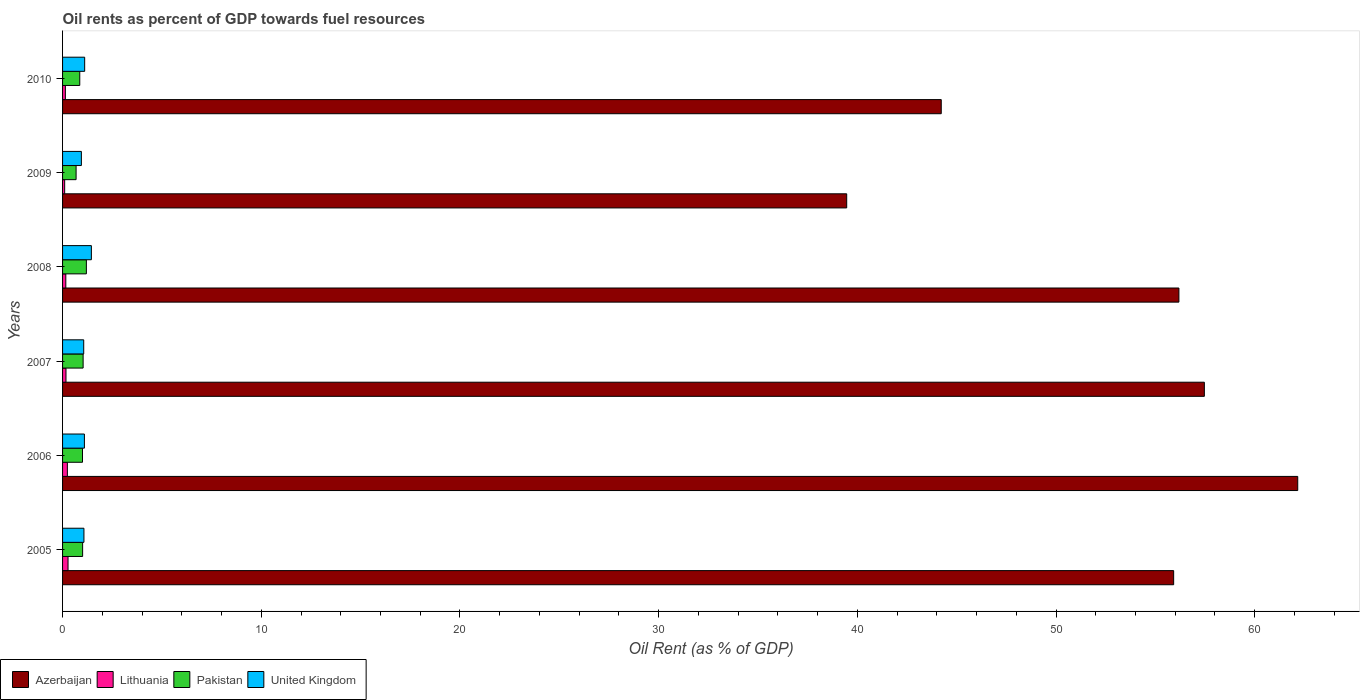Are the number of bars per tick equal to the number of legend labels?
Your answer should be compact. Yes. Are the number of bars on each tick of the Y-axis equal?
Keep it short and to the point. Yes. How many bars are there on the 4th tick from the top?
Ensure brevity in your answer.  4. What is the label of the 1st group of bars from the top?
Provide a succinct answer. 2010. In how many cases, is the number of bars for a given year not equal to the number of legend labels?
Your answer should be compact. 0. What is the oil rent in Lithuania in 2009?
Keep it short and to the point. 0.11. Across all years, what is the maximum oil rent in Pakistan?
Your response must be concise. 1.2. Across all years, what is the minimum oil rent in Azerbaijan?
Offer a very short reply. 39.47. In which year was the oil rent in Azerbaijan maximum?
Your answer should be compact. 2006. In which year was the oil rent in Azerbaijan minimum?
Your response must be concise. 2009. What is the total oil rent in Lithuania in the graph?
Provide a short and direct response. 1.1. What is the difference between the oil rent in United Kingdom in 2008 and that in 2009?
Offer a very short reply. 0.5. What is the difference between the oil rent in United Kingdom in 2009 and the oil rent in Azerbaijan in 2007?
Keep it short and to the point. -56.52. What is the average oil rent in Lithuania per year?
Your response must be concise. 0.18. In the year 2006, what is the difference between the oil rent in Lithuania and oil rent in Azerbaijan?
Your answer should be compact. -61.92. What is the ratio of the oil rent in Azerbaijan in 2005 to that in 2006?
Make the answer very short. 0.9. Is the oil rent in Pakistan in 2006 less than that in 2009?
Make the answer very short. No. What is the difference between the highest and the second highest oil rent in United Kingdom?
Your answer should be very brief. 0.34. What is the difference between the highest and the lowest oil rent in United Kingdom?
Keep it short and to the point. 0.5. Is it the case that in every year, the sum of the oil rent in Pakistan and oil rent in Lithuania is greater than the sum of oil rent in United Kingdom and oil rent in Azerbaijan?
Keep it short and to the point. No. What does the 4th bar from the top in 2008 represents?
Your answer should be compact. Azerbaijan. How many legend labels are there?
Provide a succinct answer. 4. How are the legend labels stacked?
Ensure brevity in your answer.  Horizontal. What is the title of the graph?
Your response must be concise. Oil rents as percent of GDP towards fuel resources. What is the label or title of the X-axis?
Provide a succinct answer. Oil Rent (as % of GDP). What is the label or title of the Y-axis?
Offer a very short reply. Years. What is the Oil Rent (as % of GDP) in Azerbaijan in 2005?
Provide a succinct answer. 55.92. What is the Oil Rent (as % of GDP) in Lithuania in 2005?
Offer a terse response. 0.28. What is the Oil Rent (as % of GDP) in Pakistan in 2005?
Provide a short and direct response. 1.01. What is the Oil Rent (as % of GDP) in United Kingdom in 2005?
Provide a succinct answer. 1.08. What is the Oil Rent (as % of GDP) in Azerbaijan in 2006?
Offer a terse response. 62.17. What is the Oil Rent (as % of GDP) in Lithuania in 2006?
Your answer should be very brief. 0.24. What is the Oil Rent (as % of GDP) of Pakistan in 2006?
Give a very brief answer. 1. What is the Oil Rent (as % of GDP) in United Kingdom in 2006?
Ensure brevity in your answer.  1.1. What is the Oil Rent (as % of GDP) of Azerbaijan in 2007?
Your answer should be very brief. 57.47. What is the Oil Rent (as % of GDP) in Lithuania in 2007?
Keep it short and to the point. 0.17. What is the Oil Rent (as % of GDP) of Pakistan in 2007?
Ensure brevity in your answer.  1.03. What is the Oil Rent (as % of GDP) of United Kingdom in 2007?
Keep it short and to the point. 1.06. What is the Oil Rent (as % of GDP) of Azerbaijan in 2008?
Your response must be concise. 56.19. What is the Oil Rent (as % of GDP) of Lithuania in 2008?
Your response must be concise. 0.16. What is the Oil Rent (as % of GDP) in Pakistan in 2008?
Your answer should be very brief. 1.2. What is the Oil Rent (as % of GDP) in United Kingdom in 2008?
Make the answer very short. 1.45. What is the Oil Rent (as % of GDP) in Azerbaijan in 2009?
Your answer should be compact. 39.47. What is the Oil Rent (as % of GDP) in Lithuania in 2009?
Your answer should be very brief. 0.11. What is the Oil Rent (as % of GDP) in Pakistan in 2009?
Your answer should be very brief. 0.68. What is the Oil Rent (as % of GDP) of United Kingdom in 2009?
Offer a very short reply. 0.95. What is the Oil Rent (as % of GDP) in Azerbaijan in 2010?
Provide a short and direct response. 44.22. What is the Oil Rent (as % of GDP) of Lithuania in 2010?
Your answer should be very brief. 0.14. What is the Oil Rent (as % of GDP) in Pakistan in 2010?
Your answer should be very brief. 0.87. What is the Oil Rent (as % of GDP) in United Kingdom in 2010?
Keep it short and to the point. 1.11. Across all years, what is the maximum Oil Rent (as % of GDP) in Azerbaijan?
Offer a terse response. 62.17. Across all years, what is the maximum Oil Rent (as % of GDP) of Lithuania?
Ensure brevity in your answer.  0.28. Across all years, what is the maximum Oil Rent (as % of GDP) in Pakistan?
Your answer should be very brief. 1.2. Across all years, what is the maximum Oil Rent (as % of GDP) of United Kingdom?
Make the answer very short. 1.45. Across all years, what is the minimum Oil Rent (as % of GDP) of Azerbaijan?
Give a very brief answer. 39.47. Across all years, what is the minimum Oil Rent (as % of GDP) of Lithuania?
Keep it short and to the point. 0.11. Across all years, what is the minimum Oil Rent (as % of GDP) in Pakistan?
Your answer should be very brief. 0.68. Across all years, what is the minimum Oil Rent (as % of GDP) of United Kingdom?
Give a very brief answer. 0.95. What is the total Oil Rent (as % of GDP) in Azerbaijan in the graph?
Your response must be concise. 315.43. What is the total Oil Rent (as % of GDP) of Lithuania in the graph?
Your response must be concise. 1.1. What is the total Oil Rent (as % of GDP) in Pakistan in the graph?
Ensure brevity in your answer.  5.79. What is the total Oil Rent (as % of GDP) in United Kingdom in the graph?
Offer a terse response. 6.75. What is the difference between the Oil Rent (as % of GDP) in Azerbaijan in 2005 and that in 2006?
Make the answer very short. -6.24. What is the difference between the Oil Rent (as % of GDP) in Lithuania in 2005 and that in 2006?
Make the answer very short. 0.03. What is the difference between the Oil Rent (as % of GDP) of Pakistan in 2005 and that in 2006?
Give a very brief answer. 0.01. What is the difference between the Oil Rent (as % of GDP) in United Kingdom in 2005 and that in 2006?
Give a very brief answer. -0.02. What is the difference between the Oil Rent (as % of GDP) in Azerbaijan in 2005 and that in 2007?
Provide a short and direct response. -1.54. What is the difference between the Oil Rent (as % of GDP) of Lithuania in 2005 and that in 2007?
Your response must be concise. 0.1. What is the difference between the Oil Rent (as % of GDP) of Pakistan in 2005 and that in 2007?
Give a very brief answer. -0.03. What is the difference between the Oil Rent (as % of GDP) of United Kingdom in 2005 and that in 2007?
Offer a terse response. 0.01. What is the difference between the Oil Rent (as % of GDP) in Azerbaijan in 2005 and that in 2008?
Give a very brief answer. -0.26. What is the difference between the Oil Rent (as % of GDP) in Lithuania in 2005 and that in 2008?
Your response must be concise. 0.11. What is the difference between the Oil Rent (as % of GDP) in Pakistan in 2005 and that in 2008?
Your answer should be compact. -0.19. What is the difference between the Oil Rent (as % of GDP) in United Kingdom in 2005 and that in 2008?
Offer a very short reply. -0.37. What is the difference between the Oil Rent (as % of GDP) of Azerbaijan in 2005 and that in 2009?
Keep it short and to the point. 16.46. What is the difference between the Oil Rent (as % of GDP) in Lithuania in 2005 and that in 2009?
Ensure brevity in your answer.  0.17. What is the difference between the Oil Rent (as % of GDP) in Pakistan in 2005 and that in 2009?
Keep it short and to the point. 0.33. What is the difference between the Oil Rent (as % of GDP) of United Kingdom in 2005 and that in 2009?
Your response must be concise. 0.13. What is the difference between the Oil Rent (as % of GDP) in Azerbaijan in 2005 and that in 2010?
Make the answer very short. 11.7. What is the difference between the Oil Rent (as % of GDP) of Lithuania in 2005 and that in 2010?
Make the answer very short. 0.13. What is the difference between the Oil Rent (as % of GDP) in Pakistan in 2005 and that in 2010?
Offer a very short reply. 0.14. What is the difference between the Oil Rent (as % of GDP) of United Kingdom in 2005 and that in 2010?
Give a very brief answer. -0.04. What is the difference between the Oil Rent (as % of GDP) of Azerbaijan in 2006 and that in 2007?
Provide a short and direct response. 4.7. What is the difference between the Oil Rent (as % of GDP) of Lithuania in 2006 and that in 2007?
Give a very brief answer. 0.07. What is the difference between the Oil Rent (as % of GDP) of Pakistan in 2006 and that in 2007?
Your answer should be very brief. -0.03. What is the difference between the Oil Rent (as % of GDP) of United Kingdom in 2006 and that in 2007?
Provide a succinct answer. 0.04. What is the difference between the Oil Rent (as % of GDP) of Azerbaijan in 2006 and that in 2008?
Give a very brief answer. 5.98. What is the difference between the Oil Rent (as % of GDP) in Lithuania in 2006 and that in 2008?
Provide a succinct answer. 0.08. What is the difference between the Oil Rent (as % of GDP) in Pakistan in 2006 and that in 2008?
Your response must be concise. -0.19. What is the difference between the Oil Rent (as % of GDP) in United Kingdom in 2006 and that in 2008?
Give a very brief answer. -0.35. What is the difference between the Oil Rent (as % of GDP) in Azerbaijan in 2006 and that in 2009?
Offer a very short reply. 22.7. What is the difference between the Oil Rent (as % of GDP) of Lithuania in 2006 and that in 2009?
Provide a succinct answer. 0.14. What is the difference between the Oil Rent (as % of GDP) in Pakistan in 2006 and that in 2009?
Ensure brevity in your answer.  0.32. What is the difference between the Oil Rent (as % of GDP) in United Kingdom in 2006 and that in 2009?
Offer a very short reply. 0.15. What is the difference between the Oil Rent (as % of GDP) of Azerbaijan in 2006 and that in 2010?
Make the answer very short. 17.94. What is the difference between the Oil Rent (as % of GDP) of Lithuania in 2006 and that in 2010?
Provide a short and direct response. 0.1. What is the difference between the Oil Rent (as % of GDP) in Pakistan in 2006 and that in 2010?
Your answer should be very brief. 0.14. What is the difference between the Oil Rent (as % of GDP) in United Kingdom in 2006 and that in 2010?
Keep it short and to the point. -0.01. What is the difference between the Oil Rent (as % of GDP) in Azerbaijan in 2007 and that in 2008?
Offer a terse response. 1.28. What is the difference between the Oil Rent (as % of GDP) of Lithuania in 2007 and that in 2008?
Keep it short and to the point. 0.01. What is the difference between the Oil Rent (as % of GDP) in Pakistan in 2007 and that in 2008?
Provide a succinct answer. -0.16. What is the difference between the Oil Rent (as % of GDP) of United Kingdom in 2007 and that in 2008?
Your answer should be very brief. -0.39. What is the difference between the Oil Rent (as % of GDP) of Azerbaijan in 2007 and that in 2009?
Your answer should be very brief. 18. What is the difference between the Oil Rent (as % of GDP) in Lithuania in 2007 and that in 2009?
Make the answer very short. 0.07. What is the difference between the Oil Rent (as % of GDP) of Pakistan in 2007 and that in 2009?
Provide a short and direct response. 0.35. What is the difference between the Oil Rent (as % of GDP) in United Kingdom in 2007 and that in 2009?
Offer a very short reply. 0.12. What is the difference between the Oil Rent (as % of GDP) in Azerbaijan in 2007 and that in 2010?
Your response must be concise. 13.24. What is the difference between the Oil Rent (as % of GDP) in Lithuania in 2007 and that in 2010?
Your answer should be compact. 0.03. What is the difference between the Oil Rent (as % of GDP) of Pakistan in 2007 and that in 2010?
Your answer should be very brief. 0.17. What is the difference between the Oil Rent (as % of GDP) in United Kingdom in 2007 and that in 2010?
Keep it short and to the point. -0.05. What is the difference between the Oil Rent (as % of GDP) in Azerbaijan in 2008 and that in 2009?
Your answer should be compact. 16.72. What is the difference between the Oil Rent (as % of GDP) of Lithuania in 2008 and that in 2009?
Your answer should be very brief. 0.06. What is the difference between the Oil Rent (as % of GDP) in Pakistan in 2008 and that in 2009?
Ensure brevity in your answer.  0.52. What is the difference between the Oil Rent (as % of GDP) of United Kingdom in 2008 and that in 2009?
Make the answer very short. 0.5. What is the difference between the Oil Rent (as % of GDP) in Azerbaijan in 2008 and that in 2010?
Offer a very short reply. 11.96. What is the difference between the Oil Rent (as % of GDP) of Lithuania in 2008 and that in 2010?
Keep it short and to the point. 0.02. What is the difference between the Oil Rent (as % of GDP) of Pakistan in 2008 and that in 2010?
Provide a short and direct response. 0.33. What is the difference between the Oil Rent (as % of GDP) in United Kingdom in 2008 and that in 2010?
Keep it short and to the point. 0.34. What is the difference between the Oil Rent (as % of GDP) of Azerbaijan in 2009 and that in 2010?
Provide a succinct answer. -4.76. What is the difference between the Oil Rent (as % of GDP) in Lithuania in 2009 and that in 2010?
Your response must be concise. -0.04. What is the difference between the Oil Rent (as % of GDP) of Pakistan in 2009 and that in 2010?
Your answer should be compact. -0.18. What is the difference between the Oil Rent (as % of GDP) of United Kingdom in 2009 and that in 2010?
Provide a short and direct response. -0.17. What is the difference between the Oil Rent (as % of GDP) in Azerbaijan in 2005 and the Oil Rent (as % of GDP) in Lithuania in 2006?
Your answer should be very brief. 55.68. What is the difference between the Oil Rent (as % of GDP) of Azerbaijan in 2005 and the Oil Rent (as % of GDP) of Pakistan in 2006?
Your response must be concise. 54.92. What is the difference between the Oil Rent (as % of GDP) of Azerbaijan in 2005 and the Oil Rent (as % of GDP) of United Kingdom in 2006?
Your answer should be very brief. 54.82. What is the difference between the Oil Rent (as % of GDP) of Lithuania in 2005 and the Oil Rent (as % of GDP) of Pakistan in 2006?
Keep it short and to the point. -0.73. What is the difference between the Oil Rent (as % of GDP) of Lithuania in 2005 and the Oil Rent (as % of GDP) of United Kingdom in 2006?
Offer a terse response. -0.82. What is the difference between the Oil Rent (as % of GDP) in Pakistan in 2005 and the Oil Rent (as % of GDP) in United Kingdom in 2006?
Your answer should be compact. -0.09. What is the difference between the Oil Rent (as % of GDP) in Azerbaijan in 2005 and the Oil Rent (as % of GDP) in Lithuania in 2007?
Keep it short and to the point. 55.75. What is the difference between the Oil Rent (as % of GDP) of Azerbaijan in 2005 and the Oil Rent (as % of GDP) of Pakistan in 2007?
Make the answer very short. 54.89. What is the difference between the Oil Rent (as % of GDP) in Azerbaijan in 2005 and the Oil Rent (as % of GDP) in United Kingdom in 2007?
Make the answer very short. 54.86. What is the difference between the Oil Rent (as % of GDP) in Lithuania in 2005 and the Oil Rent (as % of GDP) in Pakistan in 2007?
Your answer should be very brief. -0.76. What is the difference between the Oil Rent (as % of GDP) of Lithuania in 2005 and the Oil Rent (as % of GDP) of United Kingdom in 2007?
Keep it short and to the point. -0.79. What is the difference between the Oil Rent (as % of GDP) in Pakistan in 2005 and the Oil Rent (as % of GDP) in United Kingdom in 2007?
Your response must be concise. -0.06. What is the difference between the Oil Rent (as % of GDP) in Azerbaijan in 2005 and the Oil Rent (as % of GDP) in Lithuania in 2008?
Ensure brevity in your answer.  55.76. What is the difference between the Oil Rent (as % of GDP) of Azerbaijan in 2005 and the Oil Rent (as % of GDP) of Pakistan in 2008?
Your answer should be compact. 54.72. What is the difference between the Oil Rent (as % of GDP) of Azerbaijan in 2005 and the Oil Rent (as % of GDP) of United Kingdom in 2008?
Offer a terse response. 54.47. What is the difference between the Oil Rent (as % of GDP) of Lithuania in 2005 and the Oil Rent (as % of GDP) of Pakistan in 2008?
Ensure brevity in your answer.  -0.92. What is the difference between the Oil Rent (as % of GDP) of Lithuania in 2005 and the Oil Rent (as % of GDP) of United Kingdom in 2008?
Ensure brevity in your answer.  -1.17. What is the difference between the Oil Rent (as % of GDP) in Pakistan in 2005 and the Oil Rent (as % of GDP) in United Kingdom in 2008?
Keep it short and to the point. -0.44. What is the difference between the Oil Rent (as % of GDP) of Azerbaijan in 2005 and the Oil Rent (as % of GDP) of Lithuania in 2009?
Keep it short and to the point. 55.82. What is the difference between the Oil Rent (as % of GDP) of Azerbaijan in 2005 and the Oil Rent (as % of GDP) of Pakistan in 2009?
Give a very brief answer. 55.24. What is the difference between the Oil Rent (as % of GDP) of Azerbaijan in 2005 and the Oil Rent (as % of GDP) of United Kingdom in 2009?
Give a very brief answer. 54.97. What is the difference between the Oil Rent (as % of GDP) in Lithuania in 2005 and the Oil Rent (as % of GDP) in Pakistan in 2009?
Offer a terse response. -0.41. What is the difference between the Oil Rent (as % of GDP) of Lithuania in 2005 and the Oil Rent (as % of GDP) of United Kingdom in 2009?
Your response must be concise. -0.67. What is the difference between the Oil Rent (as % of GDP) in Pakistan in 2005 and the Oil Rent (as % of GDP) in United Kingdom in 2009?
Your response must be concise. 0.06. What is the difference between the Oil Rent (as % of GDP) in Azerbaijan in 2005 and the Oil Rent (as % of GDP) in Lithuania in 2010?
Offer a terse response. 55.78. What is the difference between the Oil Rent (as % of GDP) in Azerbaijan in 2005 and the Oil Rent (as % of GDP) in Pakistan in 2010?
Your answer should be compact. 55.06. What is the difference between the Oil Rent (as % of GDP) of Azerbaijan in 2005 and the Oil Rent (as % of GDP) of United Kingdom in 2010?
Offer a terse response. 54.81. What is the difference between the Oil Rent (as % of GDP) of Lithuania in 2005 and the Oil Rent (as % of GDP) of Pakistan in 2010?
Ensure brevity in your answer.  -0.59. What is the difference between the Oil Rent (as % of GDP) in Lithuania in 2005 and the Oil Rent (as % of GDP) in United Kingdom in 2010?
Your response must be concise. -0.84. What is the difference between the Oil Rent (as % of GDP) in Pakistan in 2005 and the Oil Rent (as % of GDP) in United Kingdom in 2010?
Offer a very short reply. -0.1. What is the difference between the Oil Rent (as % of GDP) in Azerbaijan in 2006 and the Oil Rent (as % of GDP) in Lithuania in 2007?
Give a very brief answer. 61.99. What is the difference between the Oil Rent (as % of GDP) of Azerbaijan in 2006 and the Oil Rent (as % of GDP) of Pakistan in 2007?
Your response must be concise. 61.13. What is the difference between the Oil Rent (as % of GDP) in Azerbaijan in 2006 and the Oil Rent (as % of GDP) in United Kingdom in 2007?
Keep it short and to the point. 61.1. What is the difference between the Oil Rent (as % of GDP) of Lithuania in 2006 and the Oil Rent (as % of GDP) of Pakistan in 2007?
Provide a succinct answer. -0.79. What is the difference between the Oil Rent (as % of GDP) of Lithuania in 2006 and the Oil Rent (as % of GDP) of United Kingdom in 2007?
Give a very brief answer. -0.82. What is the difference between the Oil Rent (as % of GDP) in Pakistan in 2006 and the Oil Rent (as % of GDP) in United Kingdom in 2007?
Ensure brevity in your answer.  -0.06. What is the difference between the Oil Rent (as % of GDP) in Azerbaijan in 2006 and the Oil Rent (as % of GDP) in Lithuania in 2008?
Provide a succinct answer. 62. What is the difference between the Oil Rent (as % of GDP) in Azerbaijan in 2006 and the Oil Rent (as % of GDP) in Pakistan in 2008?
Your response must be concise. 60.97. What is the difference between the Oil Rent (as % of GDP) in Azerbaijan in 2006 and the Oil Rent (as % of GDP) in United Kingdom in 2008?
Your answer should be very brief. 60.72. What is the difference between the Oil Rent (as % of GDP) of Lithuania in 2006 and the Oil Rent (as % of GDP) of Pakistan in 2008?
Offer a very short reply. -0.96. What is the difference between the Oil Rent (as % of GDP) in Lithuania in 2006 and the Oil Rent (as % of GDP) in United Kingdom in 2008?
Make the answer very short. -1.21. What is the difference between the Oil Rent (as % of GDP) of Pakistan in 2006 and the Oil Rent (as % of GDP) of United Kingdom in 2008?
Offer a very short reply. -0.45. What is the difference between the Oil Rent (as % of GDP) in Azerbaijan in 2006 and the Oil Rent (as % of GDP) in Lithuania in 2009?
Make the answer very short. 62.06. What is the difference between the Oil Rent (as % of GDP) of Azerbaijan in 2006 and the Oil Rent (as % of GDP) of Pakistan in 2009?
Offer a very short reply. 61.48. What is the difference between the Oil Rent (as % of GDP) in Azerbaijan in 2006 and the Oil Rent (as % of GDP) in United Kingdom in 2009?
Offer a terse response. 61.22. What is the difference between the Oil Rent (as % of GDP) in Lithuania in 2006 and the Oil Rent (as % of GDP) in Pakistan in 2009?
Keep it short and to the point. -0.44. What is the difference between the Oil Rent (as % of GDP) in Lithuania in 2006 and the Oil Rent (as % of GDP) in United Kingdom in 2009?
Your response must be concise. -0.7. What is the difference between the Oil Rent (as % of GDP) in Pakistan in 2006 and the Oil Rent (as % of GDP) in United Kingdom in 2009?
Ensure brevity in your answer.  0.06. What is the difference between the Oil Rent (as % of GDP) of Azerbaijan in 2006 and the Oil Rent (as % of GDP) of Lithuania in 2010?
Make the answer very short. 62.02. What is the difference between the Oil Rent (as % of GDP) in Azerbaijan in 2006 and the Oil Rent (as % of GDP) in Pakistan in 2010?
Provide a short and direct response. 61.3. What is the difference between the Oil Rent (as % of GDP) in Azerbaijan in 2006 and the Oil Rent (as % of GDP) in United Kingdom in 2010?
Give a very brief answer. 61.05. What is the difference between the Oil Rent (as % of GDP) of Lithuania in 2006 and the Oil Rent (as % of GDP) of Pakistan in 2010?
Your response must be concise. -0.62. What is the difference between the Oil Rent (as % of GDP) of Lithuania in 2006 and the Oil Rent (as % of GDP) of United Kingdom in 2010?
Ensure brevity in your answer.  -0.87. What is the difference between the Oil Rent (as % of GDP) in Pakistan in 2006 and the Oil Rent (as % of GDP) in United Kingdom in 2010?
Give a very brief answer. -0.11. What is the difference between the Oil Rent (as % of GDP) of Azerbaijan in 2007 and the Oil Rent (as % of GDP) of Lithuania in 2008?
Offer a terse response. 57.3. What is the difference between the Oil Rent (as % of GDP) of Azerbaijan in 2007 and the Oil Rent (as % of GDP) of Pakistan in 2008?
Provide a short and direct response. 56.27. What is the difference between the Oil Rent (as % of GDP) of Azerbaijan in 2007 and the Oil Rent (as % of GDP) of United Kingdom in 2008?
Ensure brevity in your answer.  56.02. What is the difference between the Oil Rent (as % of GDP) of Lithuania in 2007 and the Oil Rent (as % of GDP) of Pakistan in 2008?
Make the answer very short. -1.03. What is the difference between the Oil Rent (as % of GDP) of Lithuania in 2007 and the Oil Rent (as % of GDP) of United Kingdom in 2008?
Your response must be concise. -1.28. What is the difference between the Oil Rent (as % of GDP) of Pakistan in 2007 and the Oil Rent (as % of GDP) of United Kingdom in 2008?
Ensure brevity in your answer.  -0.42. What is the difference between the Oil Rent (as % of GDP) in Azerbaijan in 2007 and the Oil Rent (as % of GDP) in Lithuania in 2009?
Offer a terse response. 57.36. What is the difference between the Oil Rent (as % of GDP) in Azerbaijan in 2007 and the Oil Rent (as % of GDP) in Pakistan in 2009?
Provide a succinct answer. 56.79. What is the difference between the Oil Rent (as % of GDP) in Azerbaijan in 2007 and the Oil Rent (as % of GDP) in United Kingdom in 2009?
Offer a terse response. 56.52. What is the difference between the Oil Rent (as % of GDP) of Lithuania in 2007 and the Oil Rent (as % of GDP) of Pakistan in 2009?
Your answer should be compact. -0.51. What is the difference between the Oil Rent (as % of GDP) in Lithuania in 2007 and the Oil Rent (as % of GDP) in United Kingdom in 2009?
Your response must be concise. -0.77. What is the difference between the Oil Rent (as % of GDP) of Pakistan in 2007 and the Oil Rent (as % of GDP) of United Kingdom in 2009?
Your response must be concise. 0.09. What is the difference between the Oil Rent (as % of GDP) in Azerbaijan in 2007 and the Oil Rent (as % of GDP) in Lithuania in 2010?
Provide a succinct answer. 57.32. What is the difference between the Oil Rent (as % of GDP) in Azerbaijan in 2007 and the Oil Rent (as % of GDP) in Pakistan in 2010?
Your response must be concise. 56.6. What is the difference between the Oil Rent (as % of GDP) of Azerbaijan in 2007 and the Oil Rent (as % of GDP) of United Kingdom in 2010?
Ensure brevity in your answer.  56.35. What is the difference between the Oil Rent (as % of GDP) in Lithuania in 2007 and the Oil Rent (as % of GDP) in Pakistan in 2010?
Provide a short and direct response. -0.69. What is the difference between the Oil Rent (as % of GDP) of Lithuania in 2007 and the Oil Rent (as % of GDP) of United Kingdom in 2010?
Your answer should be very brief. -0.94. What is the difference between the Oil Rent (as % of GDP) in Pakistan in 2007 and the Oil Rent (as % of GDP) in United Kingdom in 2010?
Provide a succinct answer. -0.08. What is the difference between the Oil Rent (as % of GDP) of Azerbaijan in 2008 and the Oil Rent (as % of GDP) of Lithuania in 2009?
Provide a succinct answer. 56.08. What is the difference between the Oil Rent (as % of GDP) of Azerbaijan in 2008 and the Oil Rent (as % of GDP) of Pakistan in 2009?
Ensure brevity in your answer.  55.5. What is the difference between the Oil Rent (as % of GDP) of Azerbaijan in 2008 and the Oil Rent (as % of GDP) of United Kingdom in 2009?
Make the answer very short. 55.24. What is the difference between the Oil Rent (as % of GDP) of Lithuania in 2008 and the Oil Rent (as % of GDP) of Pakistan in 2009?
Your answer should be very brief. -0.52. What is the difference between the Oil Rent (as % of GDP) in Lithuania in 2008 and the Oil Rent (as % of GDP) in United Kingdom in 2009?
Ensure brevity in your answer.  -0.78. What is the difference between the Oil Rent (as % of GDP) in Pakistan in 2008 and the Oil Rent (as % of GDP) in United Kingdom in 2009?
Make the answer very short. 0.25. What is the difference between the Oil Rent (as % of GDP) of Azerbaijan in 2008 and the Oil Rent (as % of GDP) of Lithuania in 2010?
Offer a terse response. 56.04. What is the difference between the Oil Rent (as % of GDP) of Azerbaijan in 2008 and the Oil Rent (as % of GDP) of Pakistan in 2010?
Your answer should be very brief. 55.32. What is the difference between the Oil Rent (as % of GDP) in Azerbaijan in 2008 and the Oil Rent (as % of GDP) in United Kingdom in 2010?
Your response must be concise. 55.07. What is the difference between the Oil Rent (as % of GDP) of Lithuania in 2008 and the Oil Rent (as % of GDP) of Pakistan in 2010?
Make the answer very short. -0.7. What is the difference between the Oil Rent (as % of GDP) of Lithuania in 2008 and the Oil Rent (as % of GDP) of United Kingdom in 2010?
Your response must be concise. -0.95. What is the difference between the Oil Rent (as % of GDP) of Pakistan in 2008 and the Oil Rent (as % of GDP) of United Kingdom in 2010?
Make the answer very short. 0.09. What is the difference between the Oil Rent (as % of GDP) of Azerbaijan in 2009 and the Oil Rent (as % of GDP) of Lithuania in 2010?
Your answer should be compact. 39.32. What is the difference between the Oil Rent (as % of GDP) of Azerbaijan in 2009 and the Oil Rent (as % of GDP) of Pakistan in 2010?
Your response must be concise. 38.6. What is the difference between the Oil Rent (as % of GDP) of Azerbaijan in 2009 and the Oil Rent (as % of GDP) of United Kingdom in 2010?
Offer a very short reply. 38.35. What is the difference between the Oil Rent (as % of GDP) in Lithuania in 2009 and the Oil Rent (as % of GDP) in Pakistan in 2010?
Give a very brief answer. -0.76. What is the difference between the Oil Rent (as % of GDP) in Lithuania in 2009 and the Oil Rent (as % of GDP) in United Kingdom in 2010?
Your answer should be very brief. -1.01. What is the difference between the Oil Rent (as % of GDP) in Pakistan in 2009 and the Oil Rent (as % of GDP) in United Kingdom in 2010?
Your answer should be very brief. -0.43. What is the average Oil Rent (as % of GDP) in Azerbaijan per year?
Your response must be concise. 52.57. What is the average Oil Rent (as % of GDP) of Lithuania per year?
Provide a short and direct response. 0.18. What is the average Oil Rent (as % of GDP) of Pakistan per year?
Your answer should be compact. 0.97. What is the average Oil Rent (as % of GDP) of United Kingdom per year?
Your answer should be very brief. 1.12. In the year 2005, what is the difference between the Oil Rent (as % of GDP) of Azerbaijan and Oil Rent (as % of GDP) of Lithuania?
Your answer should be compact. 55.65. In the year 2005, what is the difference between the Oil Rent (as % of GDP) in Azerbaijan and Oil Rent (as % of GDP) in Pakistan?
Provide a succinct answer. 54.91. In the year 2005, what is the difference between the Oil Rent (as % of GDP) of Azerbaijan and Oil Rent (as % of GDP) of United Kingdom?
Give a very brief answer. 54.85. In the year 2005, what is the difference between the Oil Rent (as % of GDP) in Lithuania and Oil Rent (as % of GDP) in Pakistan?
Offer a terse response. -0.73. In the year 2005, what is the difference between the Oil Rent (as % of GDP) in Lithuania and Oil Rent (as % of GDP) in United Kingdom?
Offer a very short reply. -0.8. In the year 2005, what is the difference between the Oil Rent (as % of GDP) of Pakistan and Oil Rent (as % of GDP) of United Kingdom?
Give a very brief answer. -0.07. In the year 2006, what is the difference between the Oil Rent (as % of GDP) in Azerbaijan and Oil Rent (as % of GDP) in Lithuania?
Your answer should be very brief. 61.92. In the year 2006, what is the difference between the Oil Rent (as % of GDP) of Azerbaijan and Oil Rent (as % of GDP) of Pakistan?
Your response must be concise. 61.16. In the year 2006, what is the difference between the Oil Rent (as % of GDP) of Azerbaijan and Oil Rent (as % of GDP) of United Kingdom?
Your answer should be compact. 61.07. In the year 2006, what is the difference between the Oil Rent (as % of GDP) in Lithuania and Oil Rent (as % of GDP) in Pakistan?
Make the answer very short. -0.76. In the year 2006, what is the difference between the Oil Rent (as % of GDP) of Lithuania and Oil Rent (as % of GDP) of United Kingdom?
Give a very brief answer. -0.86. In the year 2006, what is the difference between the Oil Rent (as % of GDP) of Pakistan and Oil Rent (as % of GDP) of United Kingdom?
Provide a succinct answer. -0.1. In the year 2007, what is the difference between the Oil Rent (as % of GDP) of Azerbaijan and Oil Rent (as % of GDP) of Lithuania?
Offer a terse response. 57.29. In the year 2007, what is the difference between the Oil Rent (as % of GDP) of Azerbaijan and Oil Rent (as % of GDP) of Pakistan?
Keep it short and to the point. 56.43. In the year 2007, what is the difference between the Oil Rent (as % of GDP) in Azerbaijan and Oil Rent (as % of GDP) in United Kingdom?
Your response must be concise. 56.4. In the year 2007, what is the difference between the Oil Rent (as % of GDP) of Lithuania and Oil Rent (as % of GDP) of Pakistan?
Your answer should be compact. -0.86. In the year 2007, what is the difference between the Oil Rent (as % of GDP) of Lithuania and Oil Rent (as % of GDP) of United Kingdom?
Ensure brevity in your answer.  -0.89. In the year 2007, what is the difference between the Oil Rent (as % of GDP) of Pakistan and Oil Rent (as % of GDP) of United Kingdom?
Provide a succinct answer. -0.03. In the year 2008, what is the difference between the Oil Rent (as % of GDP) in Azerbaijan and Oil Rent (as % of GDP) in Lithuania?
Keep it short and to the point. 56.02. In the year 2008, what is the difference between the Oil Rent (as % of GDP) of Azerbaijan and Oil Rent (as % of GDP) of Pakistan?
Provide a succinct answer. 54.99. In the year 2008, what is the difference between the Oil Rent (as % of GDP) in Azerbaijan and Oil Rent (as % of GDP) in United Kingdom?
Offer a very short reply. 54.74. In the year 2008, what is the difference between the Oil Rent (as % of GDP) of Lithuania and Oil Rent (as % of GDP) of Pakistan?
Your answer should be very brief. -1.03. In the year 2008, what is the difference between the Oil Rent (as % of GDP) of Lithuania and Oil Rent (as % of GDP) of United Kingdom?
Give a very brief answer. -1.29. In the year 2008, what is the difference between the Oil Rent (as % of GDP) in Pakistan and Oil Rent (as % of GDP) in United Kingdom?
Make the answer very short. -0.25. In the year 2009, what is the difference between the Oil Rent (as % of GDP) of Azerbaijan and Oil Rent (as % of GDP) of Lithuania?
Provide a succinct answer. 39.36. In the year 2009, what is the difference between the Oil Rent (as % of GDP) of Azerbaijan and Oil Rent (as % of GDP) of Pakistan?
Offer a very short reply. 38.78. In the year 2009, what is the difference between the Oil Rent (as % of GDP) of Azerbaijan and Oil Rent (as % of GDP) of United Kingdom?
Your answer should be very brief. 38.52. In the year 2009, what is the difference between the Oil Rent (as % of GDP) in Lithuania and Oil Rent (as % of GDP) in Pakistan?
Your answer should be very brief. -0.57. In the year 2009, what is the difference between the Oil Rent (as % of GDP) in Lithuania and Oil Rent (as % of GDP) in United Kingdom?
Make the answer very short. -0.84. In the year 2009, what is the difference between the Oil Rent (as % of GDP) in Pakistan and Oil Rent (as % of GDP) in United Kingdom?
Offer a terse response. -0.27. In the year 2010, what is the difference between the Oil Rent (as % of GDP) of Azerbaijan and Oil Rent (as % of GDP) of Lithuania?
Give a very brief answer. 44.08. In the year 2010, what is the difference between the Oil Rent (as % of GDP) in Azerbaijan and Oil Rent (as % of GDP) in Pakistan?
Keep it short and to the point. 43.36. In the year 2010, what is the difference between the Oil Rent (as % of GDP) of Azerbaijan and Oil Rent (as % of GDP) of United Kingdom?
Provide a succinct answer. 43.11. In the year 2010, what is the difference between the Oil Rent (as % of GDP) of Lithuania and Oil Rent (as % of GDP) of Pakistan?
Make the answer very short. -0.72. In the year 2010, what is the difference between the Oil Rent (as % of GDP) of Lithuania and Oil Rent (as % of GDP) of United Kingdom?
Provide a succinct answer. -0.97. In the year 2010, what is the difference between the Oil Rent (as % of GDP) of Pakistan and Oil Rent (as % of GDP) of United Kingdom?
Ensure brevity in your answer.  -0.25. What is the ratio of the Oil Rent (as % of GDP) in Azerbaijan in 2005 to that in 2006?
Give a very brief answer. 0.9. What is the ratio of the Oil Rent (as % of GDP) in Lithuania in 2005 to that in 2006?
Offer a terse response. 1.14. What is the ratio of the Oil Rent (as % of GDP) in United Kingdom in 2005 to that in 2006?
Provide a short and direct response. 0.98. What is the ratio of the Oil Rent (as % of GDP) in Azerbaijan in 2005 to that in 2007?
Your answer should be compact. 0.97. What is the ratio of the Oil Rent (as % of GDP) in Lithuania in 2005 to that in 2007?
Keep it short and to the point. 1.6. What is the ratio of the Oil Rent (as % of GDP) of Pakistan in 2005 to that in 2007?
Provide a short and direct response. 0.98. What is the ratio of the Oil Rent (as % of GDP) of United Kingdom in 2005 to that in 2007?
Your response must be concise. 1.01. What is the ratio of the Oil Rent (as % of GDP) in Azerbaijan in 2005 to that in 2008?
Make the answer very short. 1. What is the ratio of the Oil Rent (as % of GDP) of Lithuania in 2005 to that in 2008?
Offer a very short reply. 1.68. What is the ratio of the Oil Rent (as % of GDP) of Pakistan in 2005 to that in 2008?
Your answer should be compact. 0.84. What is the ratio of the Oil Rent (as % of GDP) in United Kingdom in 2005 to that in 2008?
Provide a short and direct response. 0.74. What is the ratio of the Oil Rent (as % of GDP) of Azerbaijan in 2005 to that in 2009?
Keep it short and to the point. 1.42. What is the ratio of the Oil Rent (as % of GDP) of Pakistan in 2005 to that in 2009?
Offer a terse response. 1.48. What is the ratio of the Oil Rent (as % of GDP) of United Kingdom in 2005 to that in 2009?
Ensure brevity in your answer.  1.14. What is the ratio of the Oil Rent (as % of GDP) of Azerbaijan in 2005 to that in 2010?
Your answer should be compact. 1.26. What is the ratio of the Oil Rent (as % of GDP) of Lithuania in 2005 to that in 2010?
Give a very brief answer. 1.94. What is the ratio of the Oil Rent (as % of GDP) of Pakistan in 2005 to that in 2010?
Ensure brevity in your answer.  1.17. What is the ratio of the Oil Rent (as % of GDP) of United Kingdom in 2005 to that in 2010?
Your answer should be very brief. 0.97. What is the ratio of the Oil Rent (as % of GDP) of Azerbaijan in 2006 to that in 2007?
Offer a terse response. 1.08. What is the ratio of the Oil Rent (as % of GDP) of Lithuania in 2006 to that in 2007?
Offer a very short reply. 1.41. What is the ratio of the Oil Rent (as % of GDP) in Pakistan in 2006 to that in 2007?
Your answer should be very brief. 0.97. What is the ratio of the Oil Rent (as % of GDP) in United Kingdom in 2006 to that in 2007?
Offer a terse response. 1.03. What is the ratio of the Oil Rent (as % of GDP) in Azerbaijan in 2006 to that in 2008?
Provide a short and direct response. 1.11. What is the ratio of the Oil Rent (as % of GDP) in Lithuania in 2006 to that in 2008?
Provide a short and direct response. 1.48. What is the ratio of the Oil Rent (as % of GDP) of Pakistan in 2006 to that in 2008?
Your answer should be compact. 0.84. What is the ratio of the Oil Rent (as % of GDP) in United Kingdom in 2006 to that in 2008?
Ensure brevity in your answer.  0.76. What is the ratio of the Oil Rent (as % of GDP) in Azerbaijan in 2006 to that in 2009?
Give a very brief answer. 1.58. What is the ratio of the Oil Rent (as % of GDP) in Lithuania in 2006 to that in 2009?
Give a very brief answer. 2.28. What is the ratio of the Oil Rent (as % of GDP) in Pakistan in 2006 to that in 2009?
Offer a terse response. 1.47. What is the ratio of the Oil Rent (as % of GDP) in United Kingdom in 2006 to that in 2009?
Make the answer very short. 1.16. What is the ratio of the Oil Rent (as % of GDP) of Azerbaijan in 2006 to that in 2010?
Give a very brief answer. 1.41. What is the ratio of the Oil Rent (as % of GDP) in Lithuania in 2006 to that in 2010?
Provide a short and direct response. 1.71. What is the ratio of the Oil Rent (as % of GDP) of Pakistan in 2006 to that in 2010?
Your answer should be very brief. 1.16. What is the ratio of the Oil Rent (as % of GDP) of United Kingdom in 2006 to that in 2010?
Make the answer very short. 0.99. What is the ratio of the Oil Rent (as % of GDP) of Azerbaijan in 2007 to that in 2008?
Your answer should be compact. 1.02. What is the ratio of the Oil Rent (as % of GDP) of Lithuania in 2007 to that in 2008?
Your answer should be compact. 1.05. What is the ratio of the Oil Rent (as % of GDP) in Pakistan in 2007 to that in 2008?
Keep it short and to the point. 0.86. What is the ratio of the Oil Rent (as % of GDP) in United Kingdom in 2007 to that in 2008?
Give a very brief answer. 0.73. What is the ratio of the Oil Rent (as % of GDP) in Azerbaijan in 2007 to that in 2009?
Give a very brief answer. 1.46. What is the ratio of the Oil Rent (as % of GDP) in Lithuania in 2007 to that in 2009?
Keep it short and to the point. 1.63. What is the ratio of the Oil Rent (as % of GDP) in Pakistan in 2007 to that in 2009?
Provide a succinct answer. 1.52. What is the ratio of the Oil Rent (as % of GDP) of United Kingdom in 2007 to that in 2009?
Provide a succinct answer. 1.12. What is the ratio of the Oil Rent (as % of GDP) in Azerbaijan in 2007 to that in 2010?
Your answer should be compact. 1.3. What is the ratio of the Oil Rent (as % of GDP) in Lithuania in 2007 to that in 2010?
Your answer should be compact. 1.21. What is the ratio of the Oil Rent (as % of GDP) of Pakistan in 2007 to that in 2010?
Provide a succinct answer. 1.2. What is the ratio of the Oil Rent (as % of GDP) in United Kingdom in 2007 to that in 2010?
Keep it short and to the point. 0.96. What is the ratio of the Oil Rent (as % of GDP) in Azerbaijan in 2008 to that in 2009?
Provide a succinct answer. 1.42. What is the ratio of the Oil Rent (as % of GDP) in Lithuania in 2008 to that in 2009?
Provide a short and direct response. 1.55. What is the ratio of the Oil Rent (as % of GDP) of Pakistan in 2008 to that in 2009?
Offer a very short reply. 1.76. What is the ratio of the Oil Rent (as % of GDP) of United Kingdom in 2008 to that in 2009?
Your answer should be very brief. 1.53. What is the ratio of the Oil Rent (as % of GDP) of Azerbaijan in 2008 to that in 2010?
Make the answer very short. 1.27. What is the ratio of the Oil Rent (as % of GDP) of Lithuania in 2008 to that in 2010?
Ensure brevity in your answer.  1.15. What is the ratio of the Oil Rent (as % of GDP) in Pakistan in 2008 to that in 2010?
Keep it short and to the point. 1.38. What is the ratio of the Oil Rent (as % of GDP) in United Kingdom in 2008 to that in 2010?
Your answer should be compact. 1.3. What is the ratio of the Oil Rent (as % of GDP) in Azerbaijan in 2009 to that in 2010?
Provide a short and direct response. 0.89. What is the ratio of the Oil Rent (as % of GDP) of Lithuania in 2009 to that in 2010?
Provide a short and direct response. 0.75. What is the ratio of the Oil Rent (as % of GDP) in Pakistan in 2009 to that in 2010?
Keep it short and to the point. 0.79. What is the ratio of the Oil Rent (as % of GDP) of United Kingdom in 2009 to that in 2010?
Give a very brief answer. 0.85. What is the difference between the highest and the second highest Oil Rent (as % of GDP) in Azerbaijan?
Offer a terse response. 4.7. What is the difference between the highest and the second highest Oil Rent (as % of GDP) in Lithuania?
Your response must be concise. 0.03. What is the difference between the highest and the second highest Oil Rent (as % of GDP) of Pakistan?
Offer a very short reply. 0.16. What is the difference between the highest and the second highest Oil Rent (as % of GDP) of United Kingdom?
Your answer should be compact. 0.34. What is the difference between the highest and the lowest Oil Rent (as % of GDP) of Azerbaijan?
Make the answer very short. 22.7. What is the difference between the highest and the lowest Oil Rent (as % of GDP) of Lithuania?
Provide a succinct answer. 0.17. What is the difference between the highest and the lowest Oil Rent (as % of GDP) of Pakistan?
Provide a succinct answer. 0.52. What is the difference between the highest and the lowest Oil Rent (as % of GDP) of United Kingdom?
Provide a short and direct response. 0.5. 